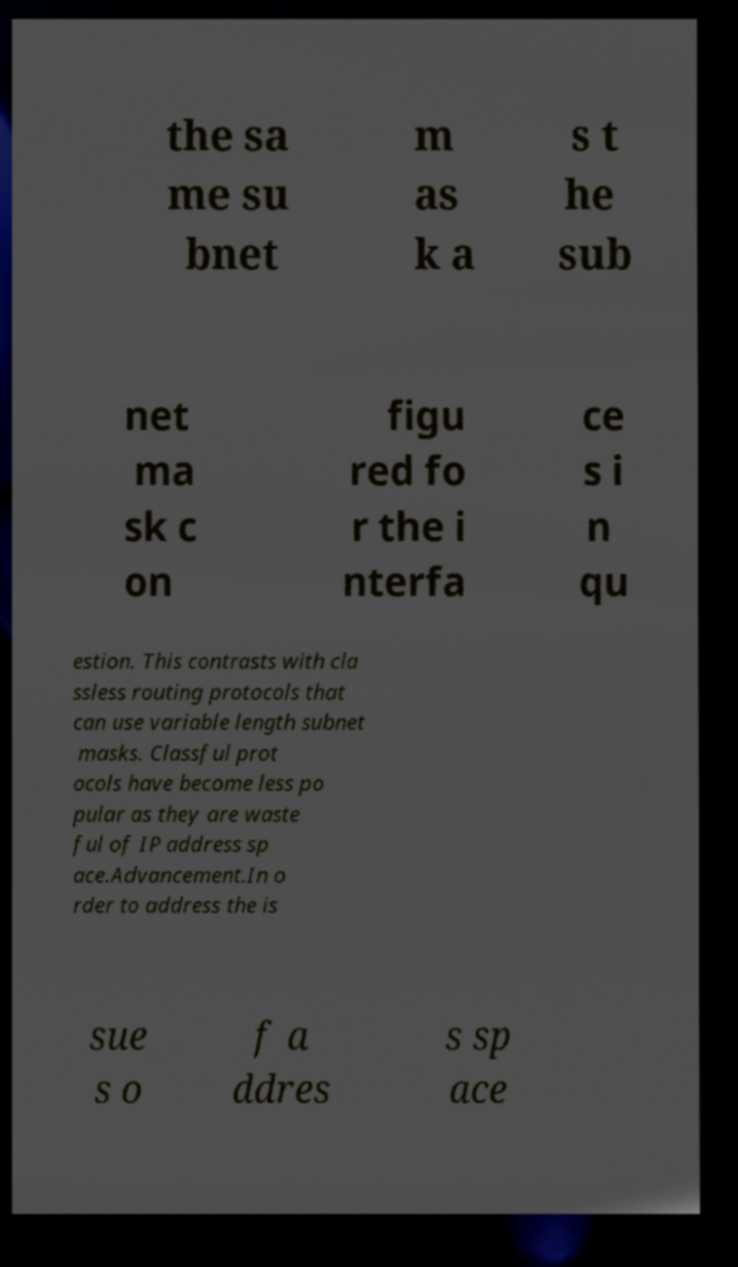Can you accurately transcribe the text from the provided image for me? the sa me su bnet m as k a s t he sub net ma sk c on figu red fo r the i nterfa ce s i n qu estion. This contrasts with cla ssless routing protocols that can use variable length subnet masks. Classful prot ocols have become less po pular as they are waste ful of IP address sp ace.Advancement.In o rder to address the is sue s o f a ddres s sp ace 